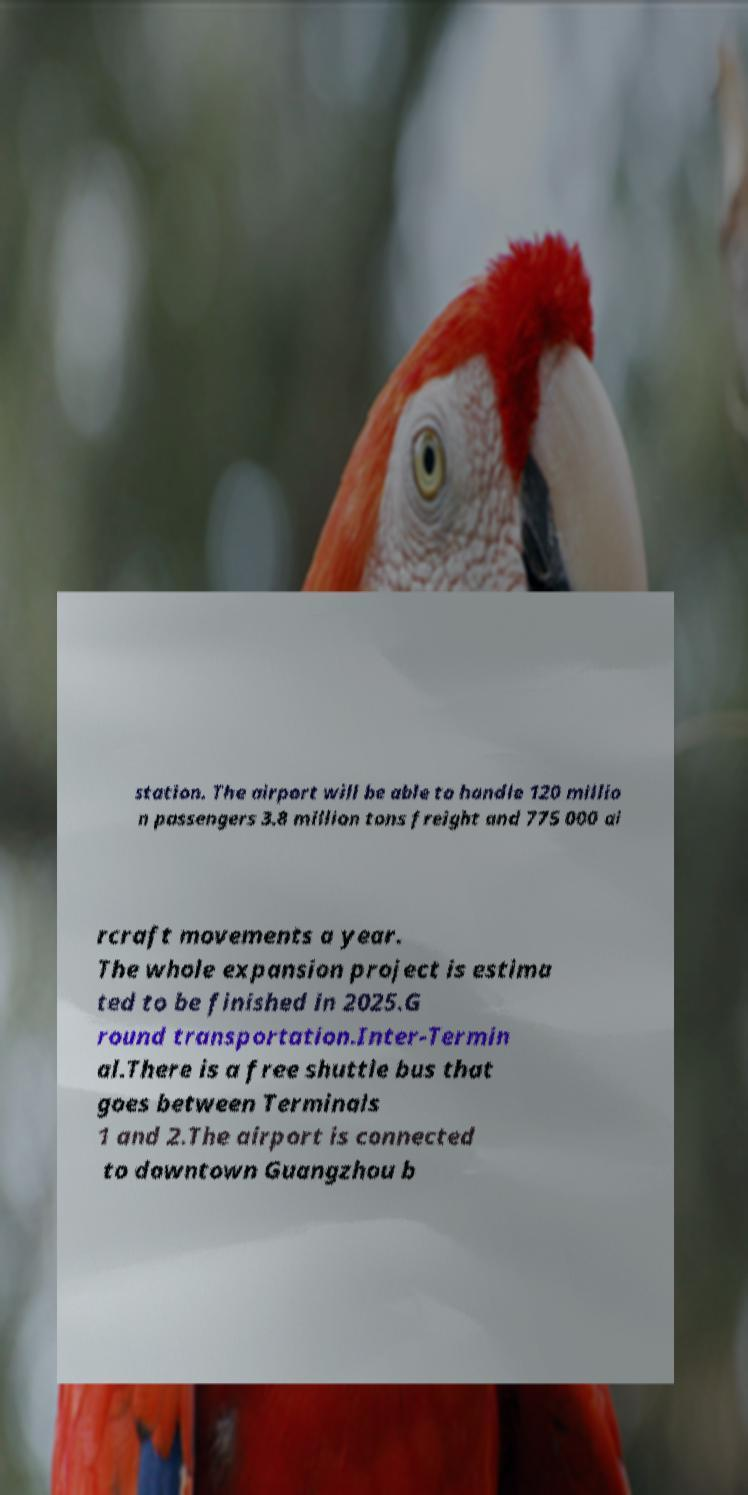Could you extract and type out the text from this image? station. The airport will be able to handle 120 millio n passengers 3.8 million tons freight and 775 000 ai rcraft movements a year. The whole expansion project is estima ted to be finished in 2025.G round transportation.Inter-Termin al.There is a free shuttle bus that goes between Terminals 1 and 2.The airport is connected to downtown Guangzhou b 